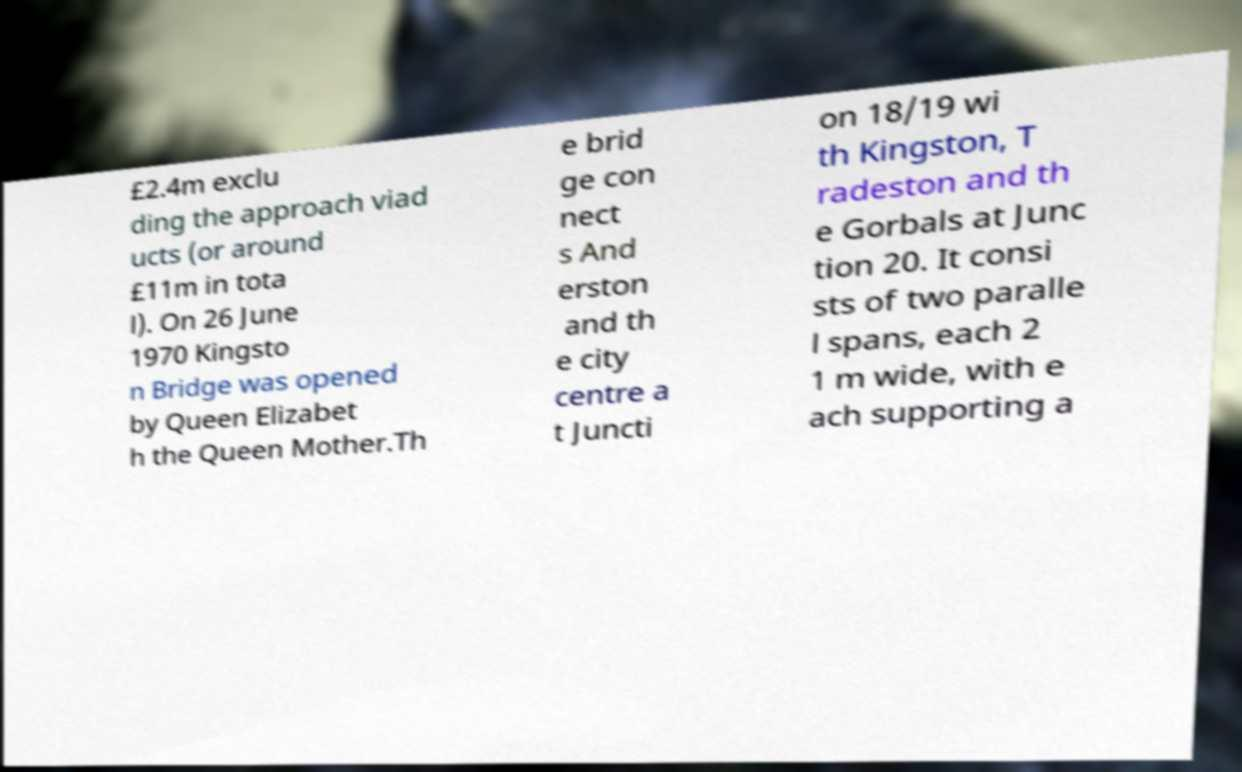I need the written content from this picture converted into text. Can you do that? £2.4m exclu ding the approach viad ucts (or around £11m in tota l). On 26 June 1970 Kingsto n Bridge was opened by Queen Elizabet h the Queen Mother.Th e brid ge con nect s And erston and th e city centre a t Juncti on 18/19 wi th Kingston, T radeston and th e Gorbals at Junc tion 20. It consi sts of two paralle l spans, each 2 1 m wide, with e ach supporting a 